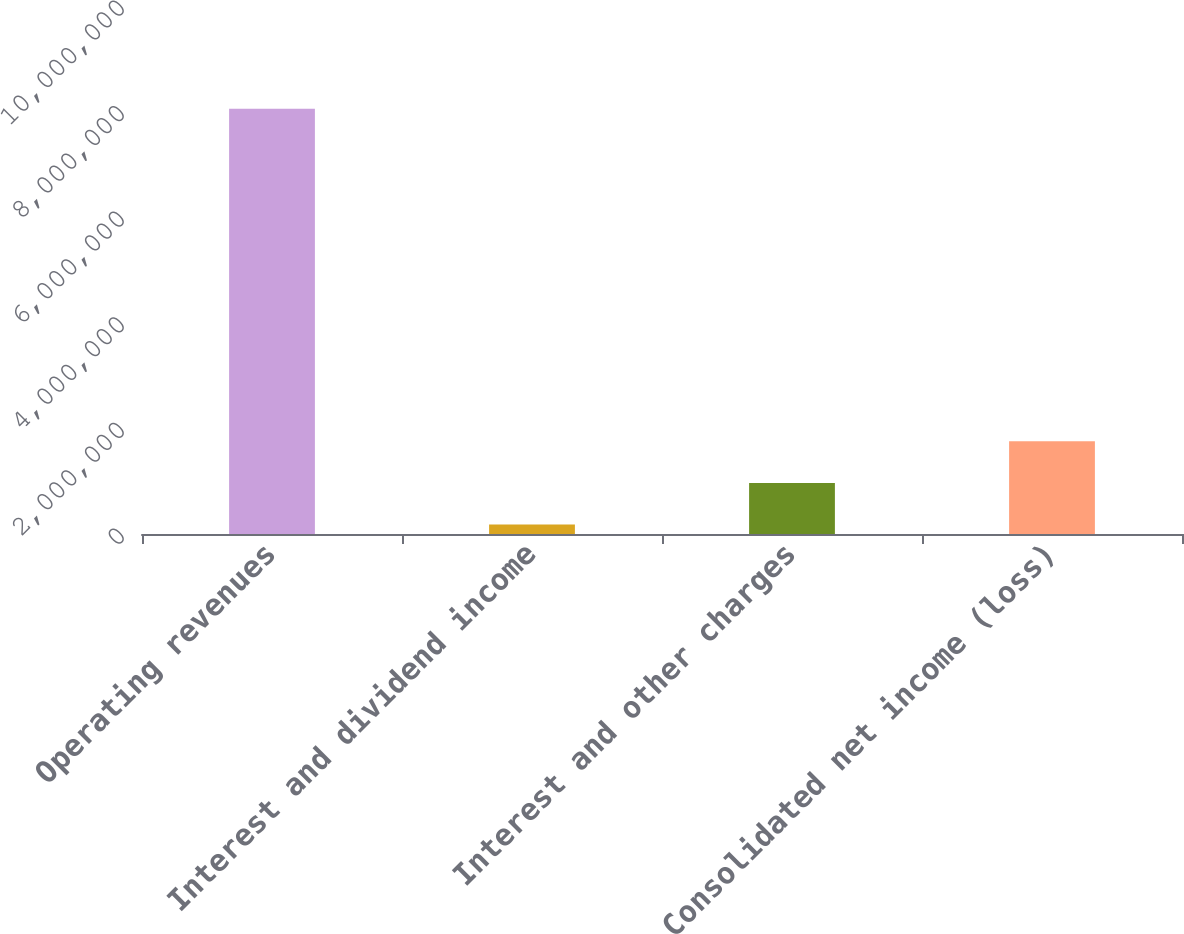<chart> <loc_0><loc_0><loc_500><loc_500><bar_chart><fcel>Operating revenues<fcel>Interest and dividend income<fcel>Interest and other charges<fcel>Consolidated net income (loss)<nl><fcel>8.05535e+06<fcel>180505<fcel>967990<fcel>1.75547e+06<nl></chart> 